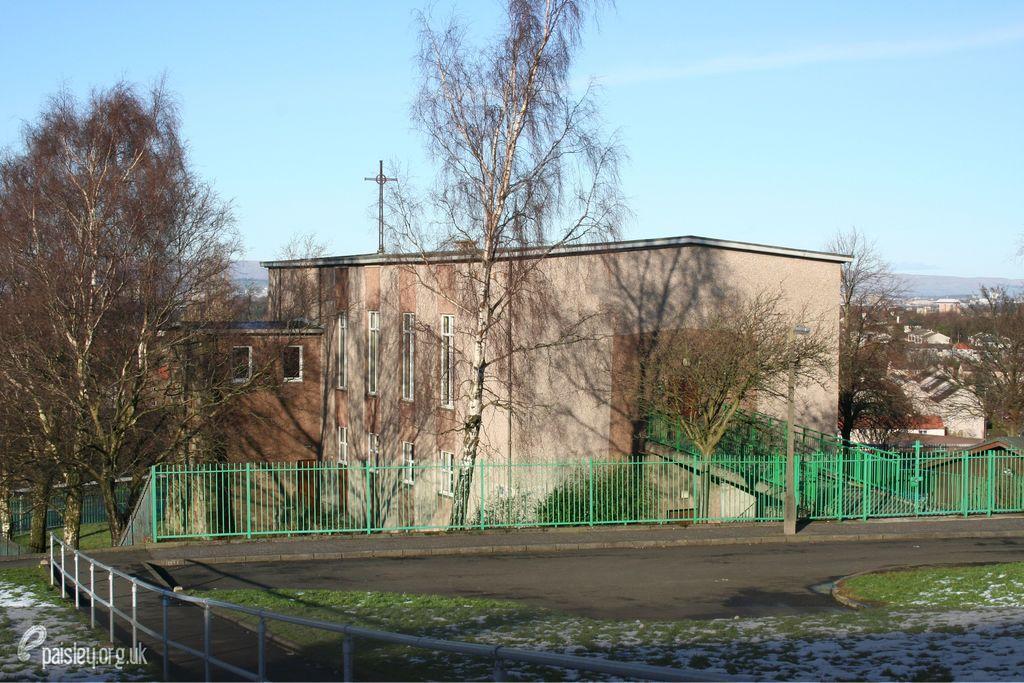Please provide a concise description of this image. In this image I can see few buildings, windows, trees, fencing, sky and the grass. 